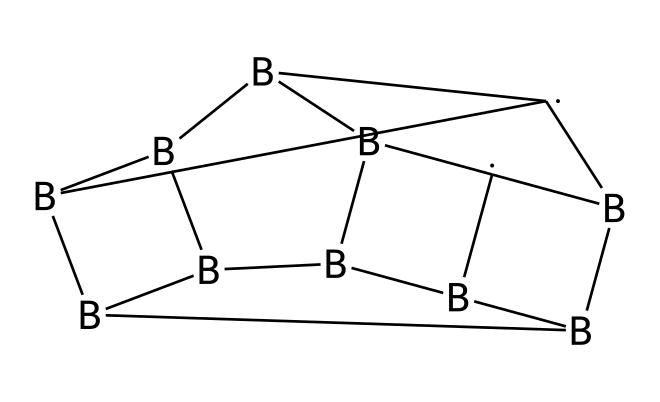How many boron atoms are in this compound? By analyzing the SMILES representation, I can count the number of occurrences of the letter "B," which indicates boron atoms. There are five instances of "B" in the molecular structure.
Answer: five What is the total number of carbon atoms in this cage compound? In the provided SMILES, the letter "C" represents carbon atoms. Counting the occurrences of "C," there are two instances indicating there are two carbon atoms in the structure.
Answer: two What kind of molecular structure is this compound known for? The compound represents a boron-carbon cage structure, which is characteristic of carboranes. The arrangement shows a complex, polyhedral structure, common in this class of compounds.
Answer: cage structure How many total atoms are in this compound? To find the total number of atoms, we add the number of boron atoms (five) and carbon atoms (two). The total is seven atoms.
Answer: seven Is this compound commonly used in cancer therapy? Carboranes, which this compound is an example of, are indeed typically utilized in cancer therapy due to their unique properties and stability, making them suitable for therapeutic applications.
Answer: yes What type of bonding characterizes the connections in this compound? The bonding in boron-carbon cage compounds like this one includes covalent bonds, which are formed between boron and carbon atoms, allowing them to share electrons and create stable structures.
Answer: covalent 